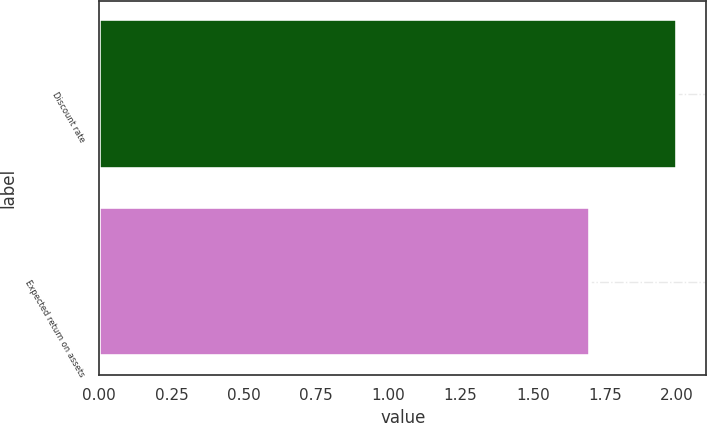<chart> <loc_0><loc_0><loc_500><loc_500><bar_chart><fcel>Discount rate<fcel>Expected return on assets<nl><fcel>2<fcel>1.7<nl></chart> 